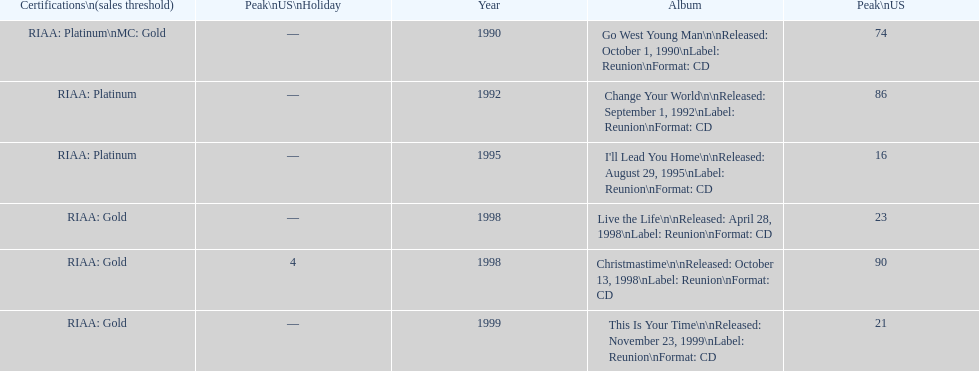How many album entries are there? 6. 